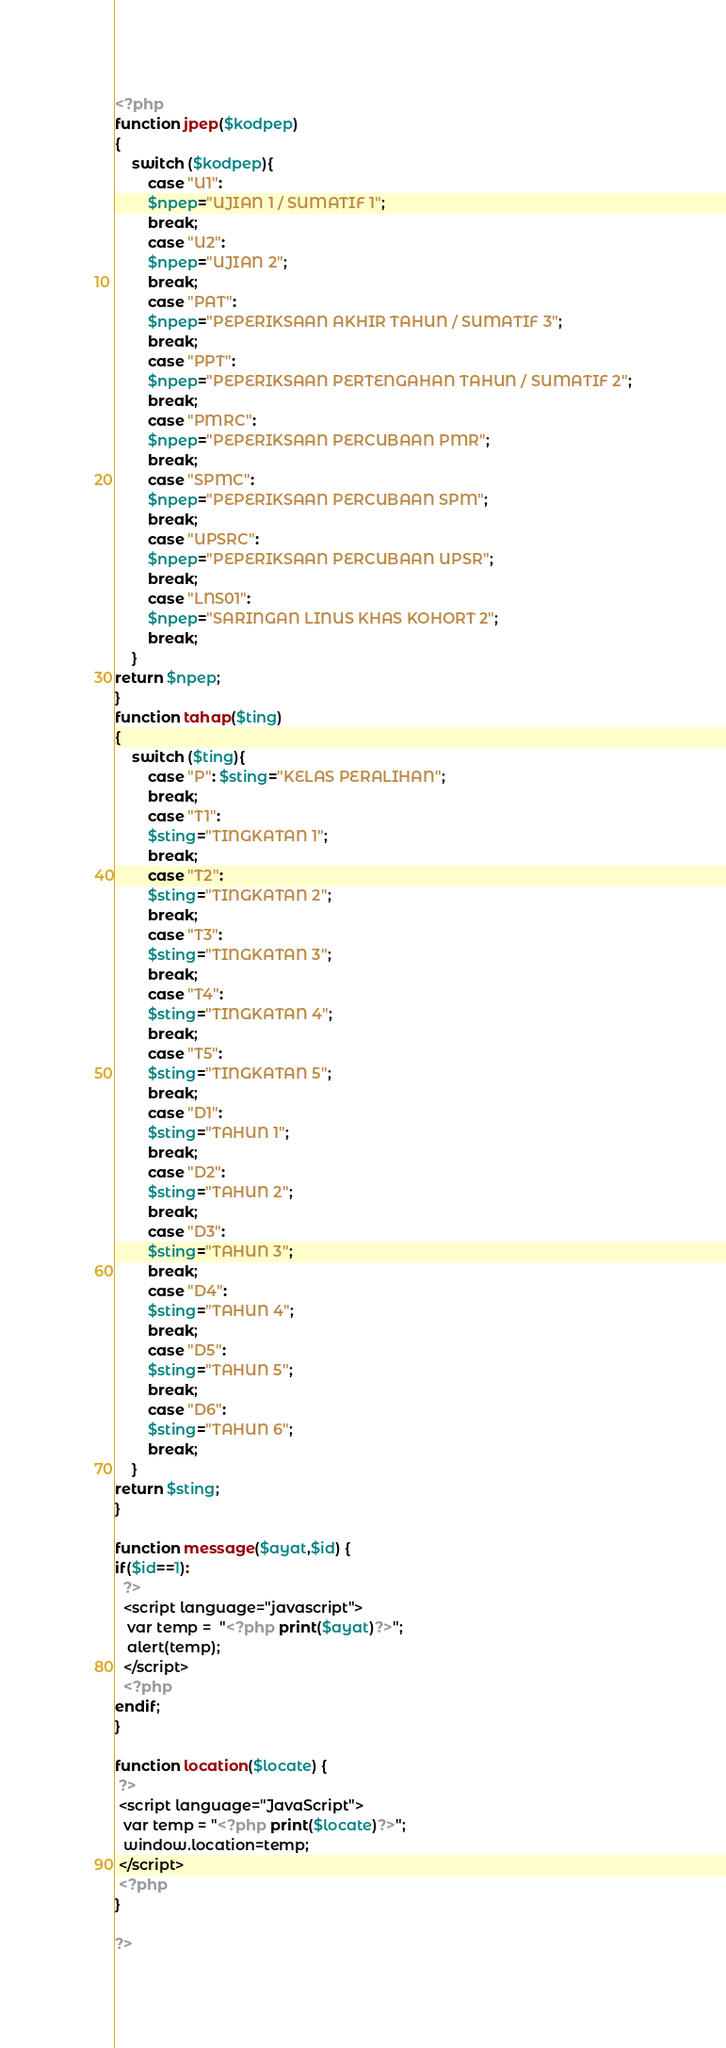Convert code to text. <code><loc_0><loc_0><loc_500><loc_500><_PHP_><?php 
function jpep($kodpep)
{
	switch ($kodpep){
		case "U1":
		$npep="UJIAN 1 / SUMATIF 1";
		break;
		case "U2":
		$npep="UJIAN 2";
		break;
		case "PAT":
		$npep="PEPERIKSAAN AKHIR TAHUN / SUMATIF 3";
		break;
		case "PPT":
		$npep="PEPERIKSAAN PERTENGAHAN TAHUN / SUMATIF 2";
		break;
		case "PMRC":
		$npep="PEPERIKSAAN PERCUBAAN PMR";
		break;
		case "SPMC":
		$npep="PEPERIKSAAN PERCUBAAN SPM";
		break;
		case "UPSRC":
		$npep="PEPERIKSAAN PERCUBAAN UPSR";
		break;
		case "LNS01":
		$npep="SARINGAN LINUS KHAS KOHORT 2";
		break;
	}
return $npep;
}
function tahap($ting)
{
	switch ($ting){
		case "P": $sting="KELAS PERALIHAN";
		break;
		case "T1":
		$sting="TINGKATAN 1";
		break;
		case "T2":
		$sting="TINGKATAN 2";
		break;
		case "T3":
		$sting="TINGKATAN 3";
		break;
		case "T4":
		$sting="TINGKATAN 4";
		break;
		case "T5":
		$sting="TINGKATAN 5";
		break;
		case "D1":
		$sting="TAHUN 1";
		break;
		case "D2":
		$sting="TAHUN 2";
		break;
		case "D3":
		$sting="TAHUN 3";
		break;
		case "D4":
		$sting="TAHUN 4";
		break;
		case "D5":
		$sting="TAHUN 5";
		break;
		case "D6":
		$sting="TAHUN 6";
		break;
	}
return $sting;
}

function message($ayat,$id) {
if($id==1):
  ?>
  <script language="javascript">
   var temp =  "<?php print($ayat)?>";
   alert(temp);
  </script>
  <?php
endif;
}

function location($locate) {
 ?>
 <script language="JavaScript">
  var temp = "<?php print($locate)?>";
  window.location=temp;
 </script>
 <?php
}

?></code> 